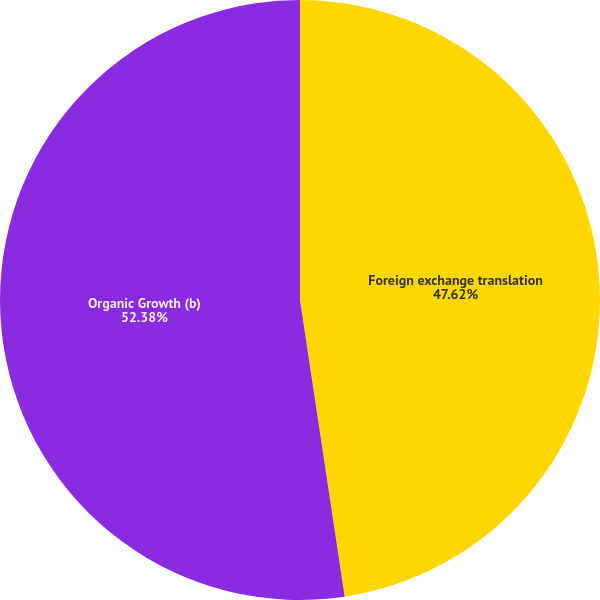Convert chart to OTSL. <chart><loc_0><loc_0><loc_500><loc_500><pie_chart><fcel>Foreign exchange translation<fcel>Organic Growth (b)<nl><fcel>47.62%<fcel>52.38%<nl></chart> 